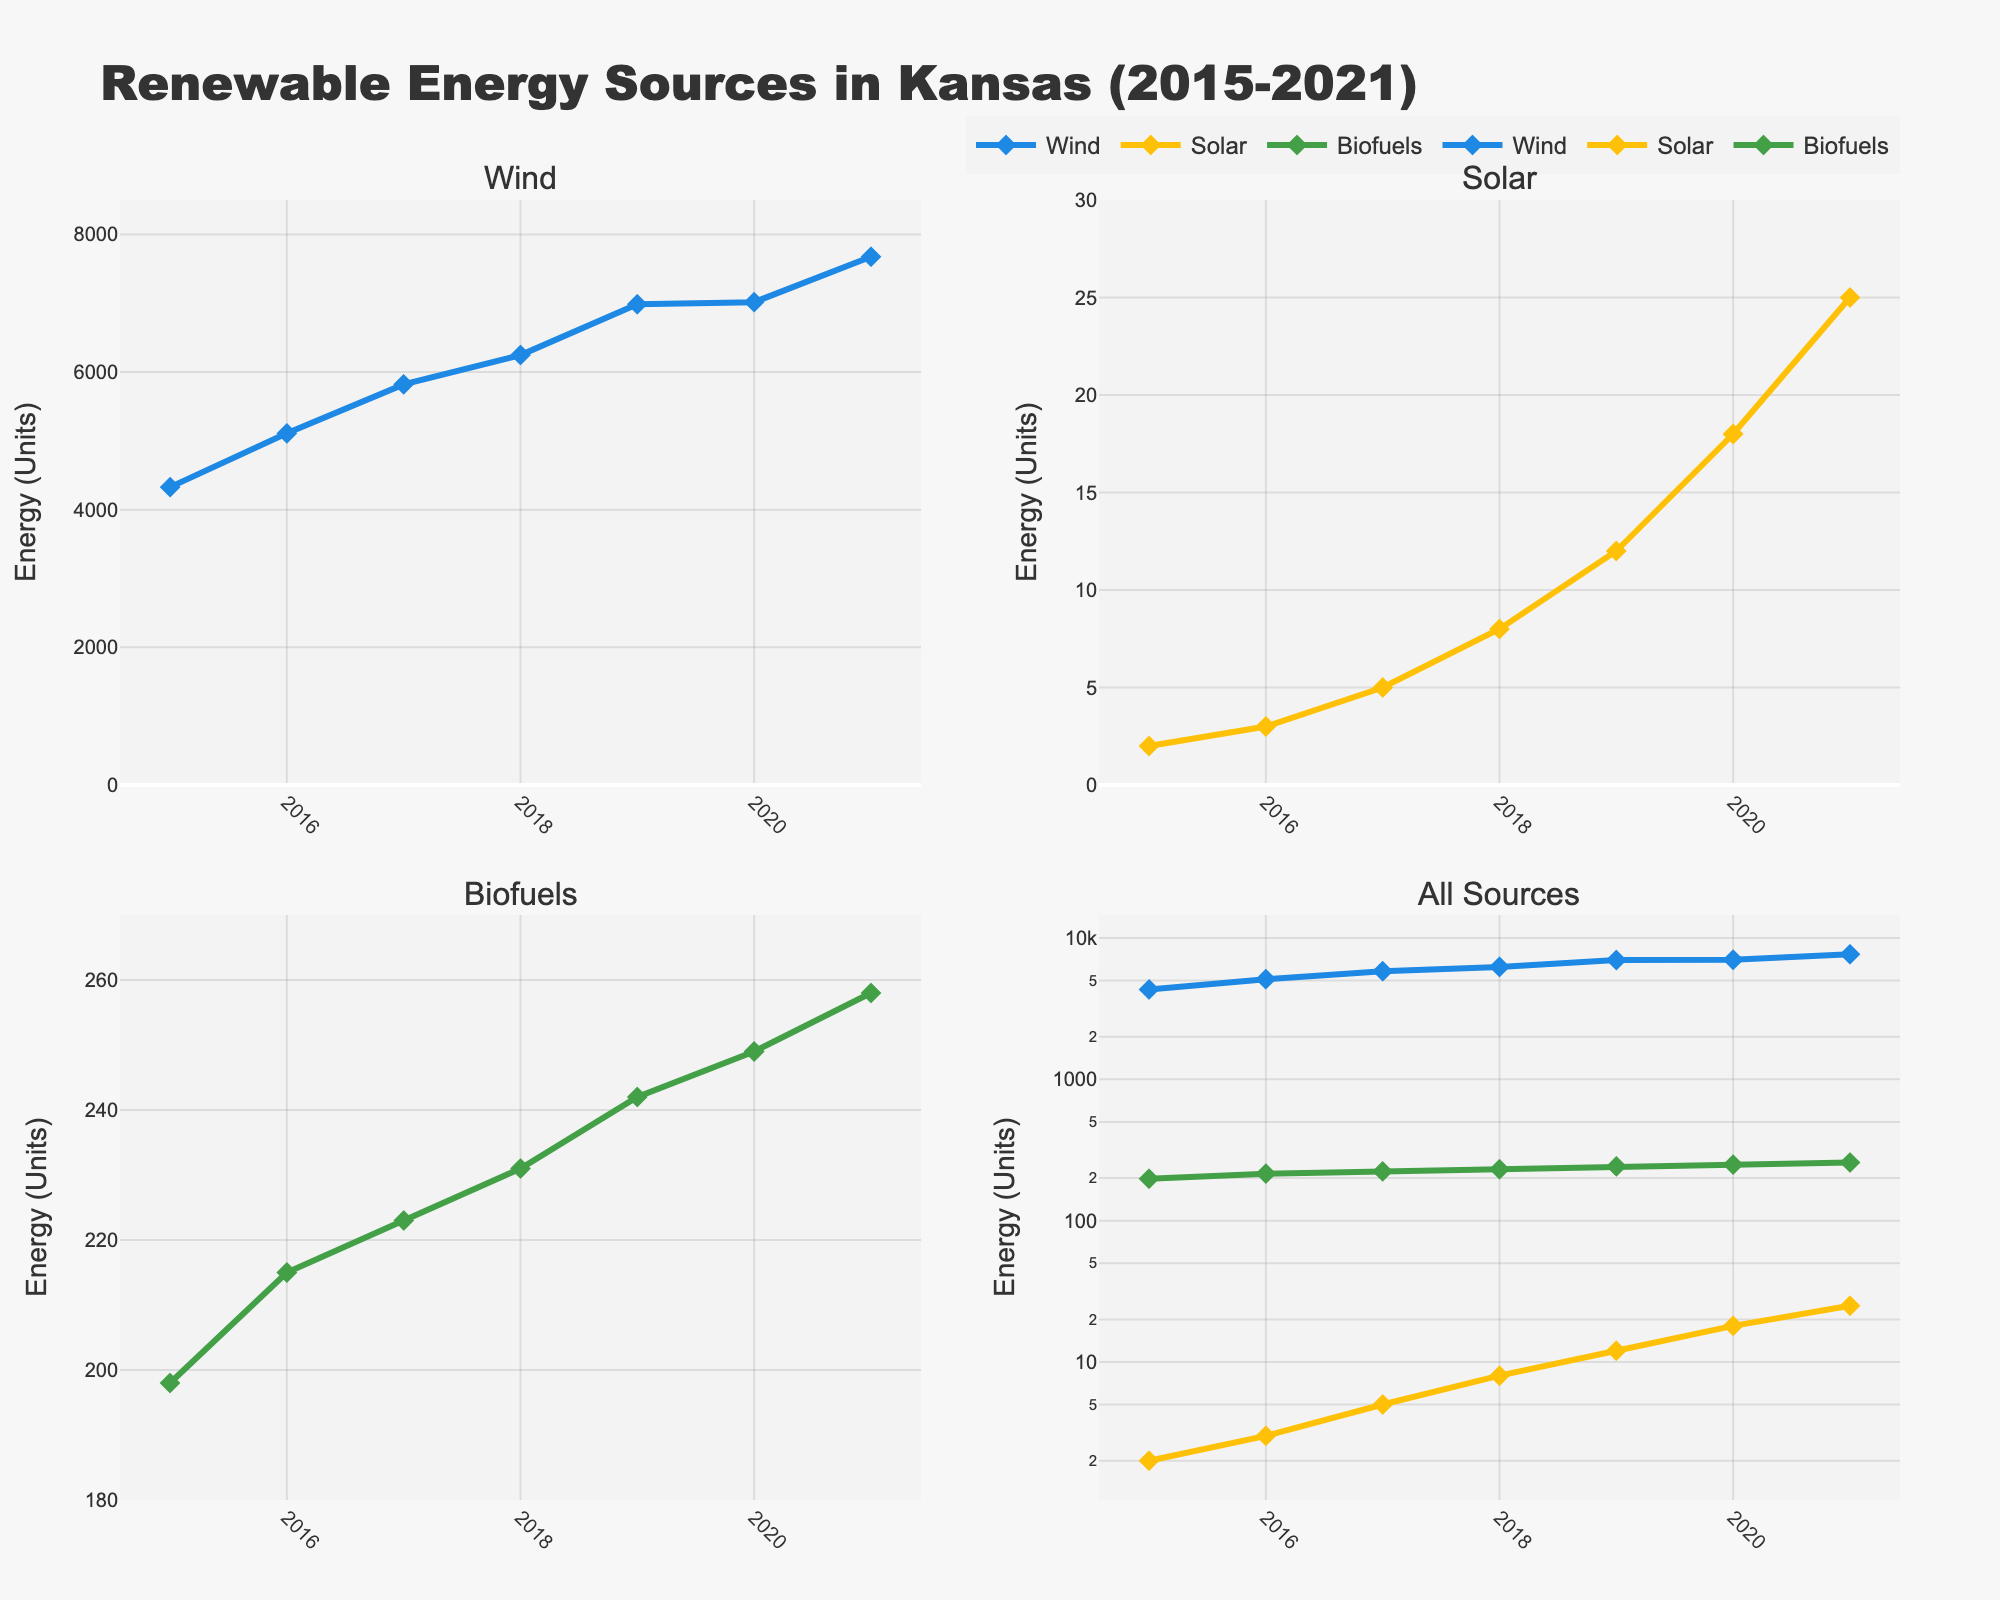What is the title of the figure? The title is located at the top center of the figure, stating the main subject of the plot. It signifies the time frame and the region of the data presented.
Answer: Renewable Energy Sources in Kansas (2015-2021) How many subplots are there? By counting the individual graph sections within the entire figure, you can see there are four subplots, organized in a 2x2 grid.
Answer: Four Which renewable energy source showed the highest energy production in 2021? In the subplots depicting each energy source separately, you can observe the y-axis values for the year 2021. The Wind subplot shows the highest value compared to Solar and Biofuels.
Answer: Wind Which subplot represents all renewable energy sources together? The fourth subplot located in the second row and second column combines the Wind, Solar, and Biofuels energy sources on a single plot.
Answer: The fourth subplot In what year did Solar energy production first exceed 10 units? By examining the Solar subplot (first row, second column), look for the first data point above 10 units. This occurs in the year 2019.
Answer: 2019 Estimate the difference in Wind energy production between 2016 and 2019. Identify the Wind energy values for 2016 (5110) and 2019 (6985) from the first subplot. The difference is calculated as 6985 - 5110 = 1875.
Answer: 1875 How do the growth rates of Solar and Biofuels compare from 2015 to 2021? By comparing the increasing trends in the Solar and Biofuels subplots, we see Solar increased from 2 to 25 units and Biofuels from 198 to 258 units. The Solar energy shows a sharper increase compared to Biofuels.
Answer: Solar grew faster than Biofuels Which energy source has the highest y-axis range in its subplot? Observing the y-axis ranges across Wind, Solar, and Biofuels subplots, Wind has the highest range (0 to 8500 units).
Answer: Wind What is the purpose of using logarithmic scale in the fourth subplot? The fourth subplot uses a logarithmic scale on the y-axis to better visualize the wide range of values across different energy sources. Without logarithmic scaling, the vast differences in magnitude would make it hard to compare in a single plot.
Answer: To better visualize wide range of values Between which years did Biofuels experience consistent growth every year? From the Biofuels subplot (second row, first column), observe that Biofuels values increased steadily each year from 2015 to 2021.
Answer: 2015 to 2021 